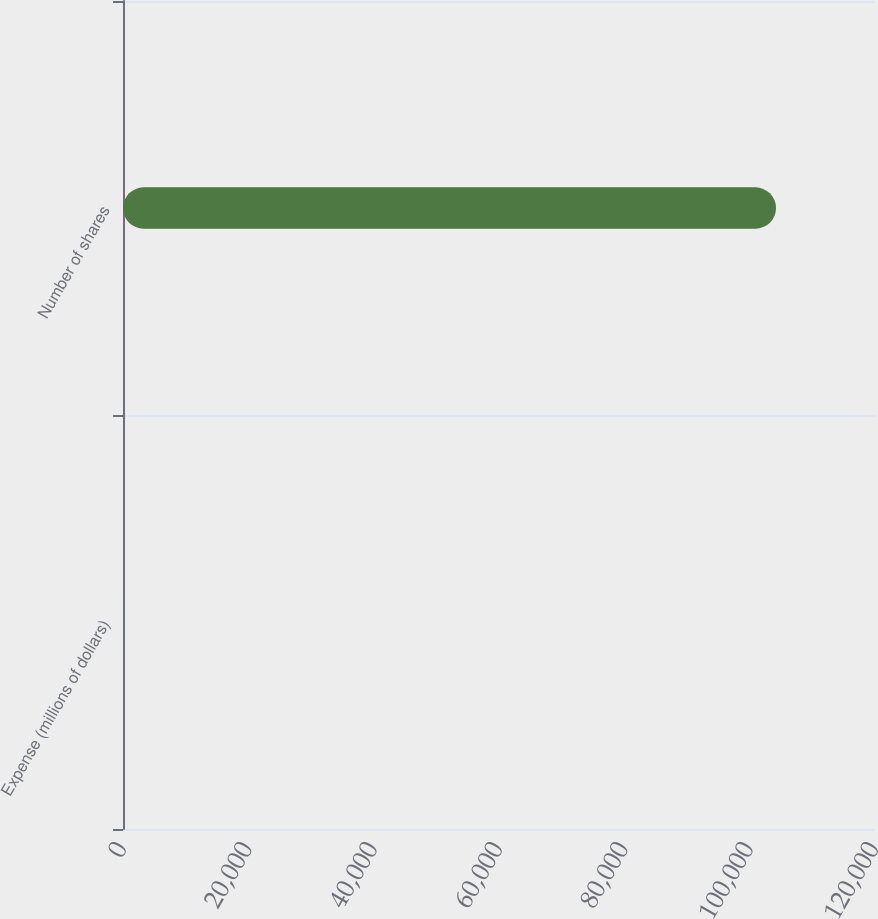Convert chart. <chart><loc_0><loc_0><loc_500><loc_500><bar_chart><fcel>Expense (millions of dollars)<fcel>Number of shares<nl><fcel>23.9<fcel>104205<nl></chart> 